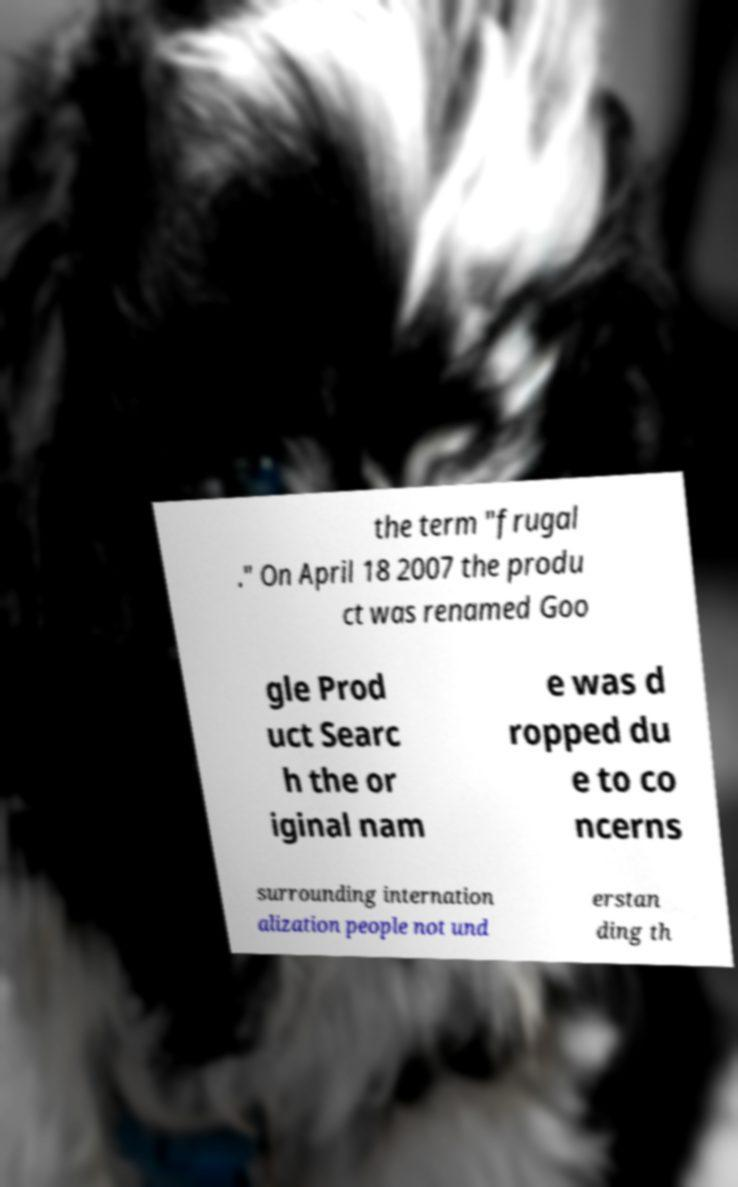What messages or text are displayed in this image? I need them in a readable, typed format. the term "frugal ." On April 18 2007 the produ ct was renamed Goo gle Prod uct Searc h the or iginal nam e was d ropped du e to co ncerns surrounding internation alization people not und erstan ding th 